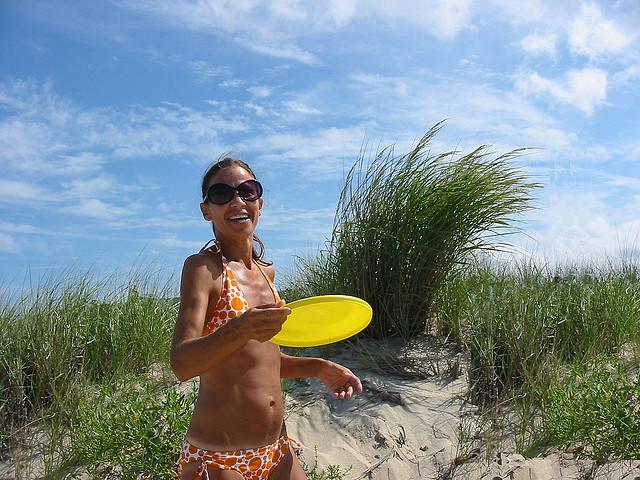Does this lady have a tan?
Short answer required. Yes. What is the lady holding?
Keep it brief. Frisbee. Is it raining?
Short answer required. No. 